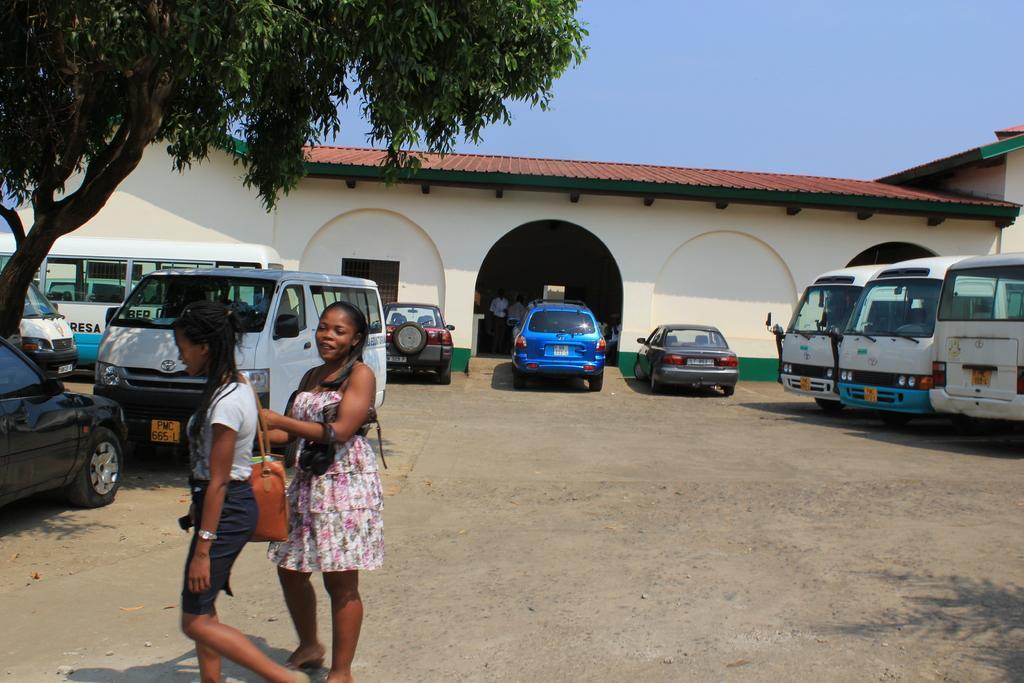Please provide a concise description of this image. In this image in front of a building there are many vehicles. In the foreground two ladies are walking. In the left there is a tree. This is the entrance of the building. The sky is clear. 